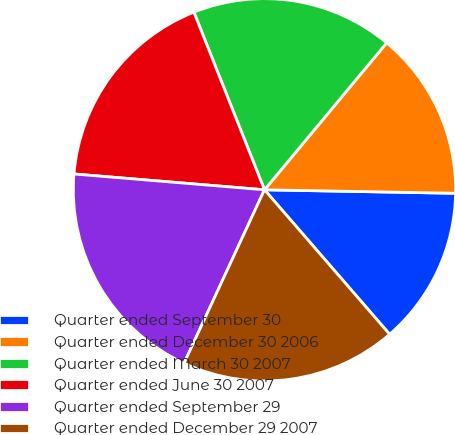Convert chart to OTSL. <chart><loc_0><loc_0><loc_500><loc_500><pie_chart><fcel>Quarter ended September 30<fcel>Quarter ended December 30 2006<fcel>Quarter ended March 30 2007<fcel>Quarter ended June 30 2007<fcel>Quarter ended September 29<fcel>Quarter ended December 29 2007<nl><fcel>13.35%<fcel>14.25%<fcel>17.06%<fcel>17.66%<fcel>19.41%<fcel>18.27%<nl></chart> 